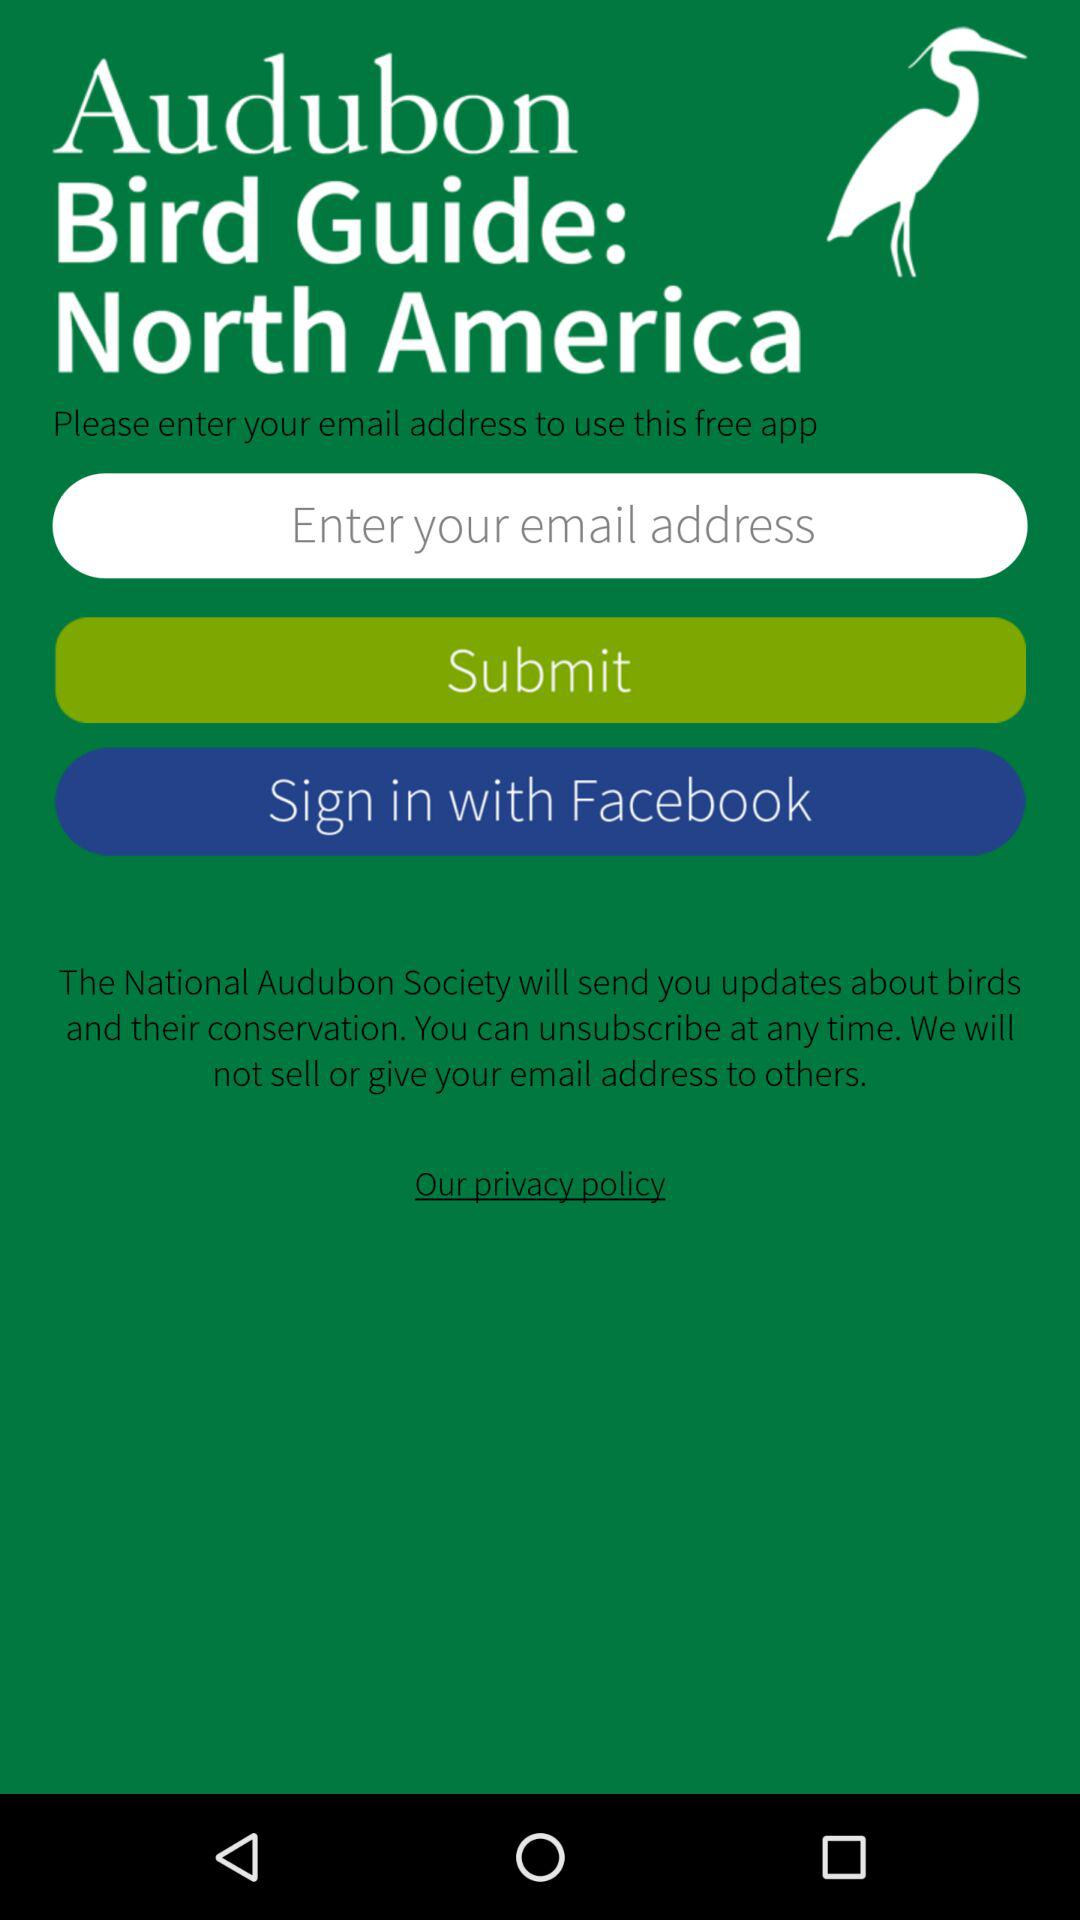What is the name of the application? The name of the application is "Audubon Bird Guide: North America". 